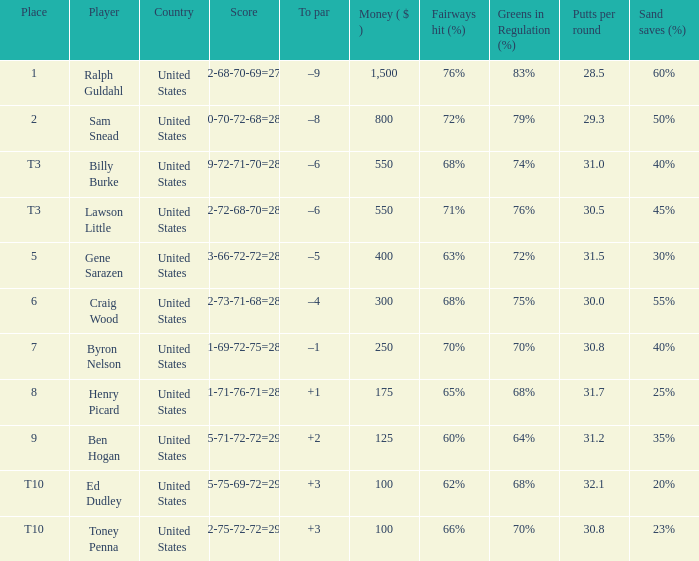Which score has a prize of $400? 73-66-72-72=283. Can you give me this table as a dict? {'header': ['Place', 'Player', 'Country', 'Score', 'To par', 'Money ( $ )', 'Fairways hit (%)', 'Greens in Regulation (%)', 'Putts per round', 'Sand saves (%) '], 'rows': [['1', 'Ralph Guldahl', 'United States', '72-68-70-69=279', '–9', '1,500', '76%', '83%', '28.5', '60%'], ['2', 'Sam Snead', 'United States', '70-70-72-68=280', '–8', '800', '72%', '79%', '29.3', '50%'], ['T3', 'Billy Burke', 'United States', '69-72-71-70=282', '–6', '550', '68%', '74%', '31.0', '40%'], ['T3', 'Lawson Little', 'United States', '72-72-68-70=282', '–6', '550', '71%', '76%', '30.5', '45%'], ['5', 'Gene Sarazen', 'United States', '73-66-72-72=283', '–5', '400', '63%', '72%', '31.5', '30%'], ['6', 'Craig Wood', 'United States', '72-73-71-68=284', '–4', '300', '68%', '75%', '30.0', '55%'], ['7', 'Byron Nelson', 'United States', '71-69-72-75=287', '–1', '250', '70%', '70%', '30.8', '40%'], ['8', 'Henry Picard', 'United States', '71-71-76-71=289', '+1', '175', '65%', '68%', '31.7', '25%'], ['9', 'Ben Hogan', 'United States', '75-71-72-72=290', '+2', '125', '60%', '64%', '31.2', '35%'], ['T10', 'Ed Dudley', 'United States', '75-75-69-72=291', '+3', '100', '62%', '68%', '32.1', '20%'], ['T10', 'Toney Penna', 'United States', '72-75-72-72=291', '+3', '100', '66%', '70%', '30.8', '23%']]} 